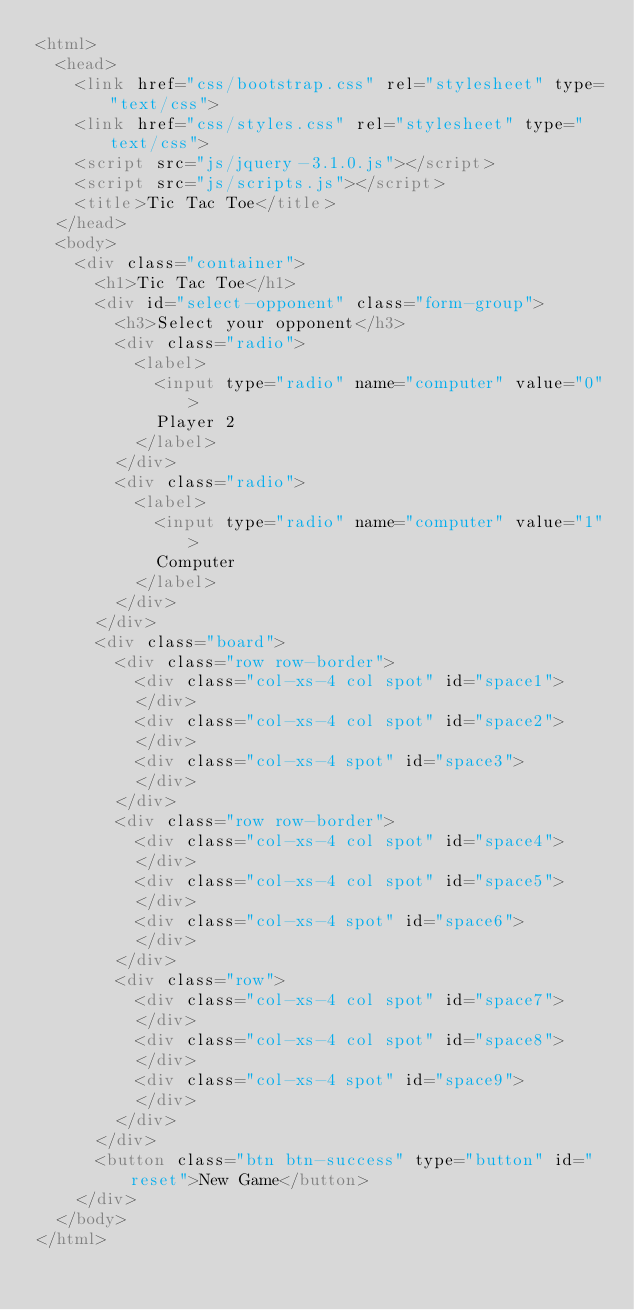<code> <loc_0><loc_0><loc_500><loc_500><_HTML_><html>
  <head>
    <link href="css/bootstrap.css" rel="stylesheet" type="text/css">
    <link href="css/styles.css" rel="stylesheet" type="text/css">
    <script src="js/jquery-3.1.0.js"></script>
    <script src="js/scripts.js"></script>
    <title>Tic Tac Toe</title>
  </head>
  <body>
    <div class="container">
      <h1>Tic Tac Toe</h1>
      <div id="select-opponent" class="form-group">
        <h3>Select your opponent</h3>
        <div class="radio">
          <label>
            <input type="radio" name="computer" value="0">
            Player 2
          </label>
        </div>
        <div class="radio">
          <label>
            <input type="radio" name="computer" value="1">
            Computer
          </label>
        </div>
      </div>
      <div class="board">
        <div class="row row-border">
          <div class="col-xs-4 col spot" id="space1">
          </div>
          <div class="col-xs-4 col spot" id="space2">
          </div>
          <div class="col-xs-4 spot" id="space3">
          </div>
        </div>
        <div class="row row-border">
          <div class="col-xs-4 col spot" id="space4">
          </div>
          <div class="col-xs-4 col spot" id="space5">
          </div>
          <div class="col-xs-4 spot" id="space6">
          </div>
        </div>
        <div class="row">
          <div class="col-xs-4 col spot" id="space7">
          </div>
          <div class="col-xs-4 col spot" id="space8">
          </div>
          <div class="col-xs-4 spot" id="space9">
          </div>
        </div>
      </div>
      <button class="btn btn-success" type="button" id="reset">New Game</button>
    </div>
  </body>
</html>
</code> 